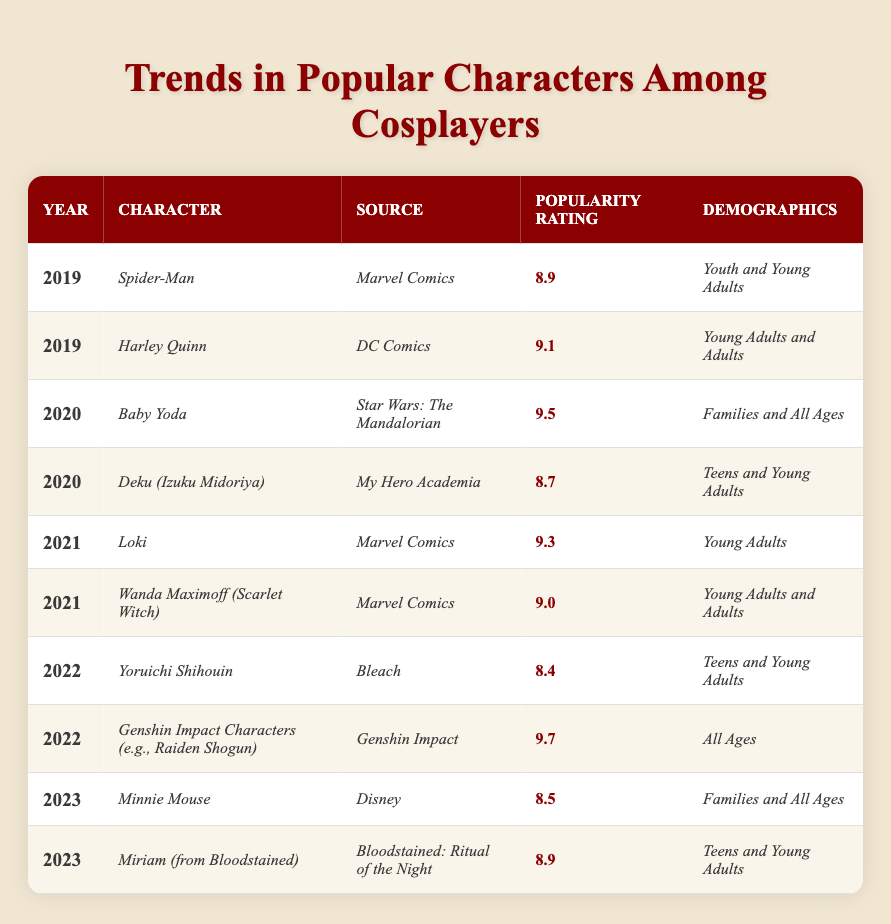What character had the highest popularity rating in 2020? Based on the table, the character with the highest popularity rating in 2020 is *Baby Yoda*, which has a rating of 9.5.
Answer: *Baby Yoda* Which character represents families and all ages in 2023? According to the table, *Minnie Mouse* from Disney represents families and all ages in 2023.
Answer: *Minnie Mouse* What is the average popularity rating of characters in 2021? The characters in 2021 are *Loki* (9.3) and *Wanda Maximoff* (9.0). The average is (9.3 + 9.0) / 2 = 9.15.
Answer: 9.15 Did *Genshin Impact Characters* have a higher popularity rating than *Yoruichi Shihouin* in 2022? *Genshin Impact Characters* have a popularity rating of 9.7 and *Yoruichi Shihouin* has 8.4. Since 9.7 > 8.4, the fact is true.
Answer: Yes How many characters had a popularity rating above 9.0 in the years 2019, 2020, and 2021 combined? The characters with ratings above 9.0 during these years are *Harley Quinn* (9.1), *Baby Yoda* (9.5), *Loki* (9.3), and *Wanda Maximoff* (9.0). That's four characters in total.
Answer: 4 What is the demographic for the character with the lowest popularity rating? The character with the lowest popularity rating is *Yoruichi Shihouin* with a rating of 8.4, and the demographics are *Teens and Young Adults*.
Answer: *Teens and Young Adults* Which character experienced a decline in popularity from 2020 to 2021? *Deku (Izuku Midoriya)* had a rating of 8.7 in 2020 and the characters in 2021 (*Loki* and *Wanda Maximoff*) had higher ratings than that, showing that *Deku (Izuku Midoriya)* experienced a relative decline.
Answer: *Deku (Izuku Midoriya)* What is the only character in the table from a Disney source? The only character from a Disney source in the table is *Minnie Mouse* in 2023.
Answer: *Minnie Mouse* 